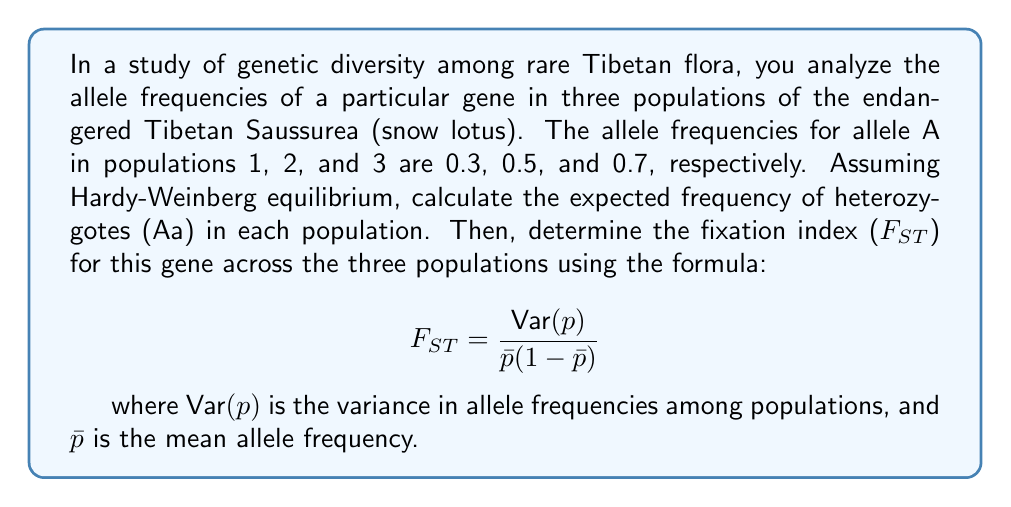Give your solution to this math problem. Let's approach this problem step by step:

1. Calculate the frequency of heterozygotes in each population:
   Under Hardy-Weinberg equilibrium, the frequency of heterozygotes is given by $2pq$, where $p$ is the frequency of allele A and $q = 1-p$ is the frequency of the other allele.

   Population 1: $2p(1-p) = 2(0.3)(0.7) = 0.42$
   Population 2: $2p(1-p) = 2(0.5)(0.5) = 0.50$
   Population 3: $2p(1-p) = 2(0.7)(0.3) = 0.42$

2. Calculate the mean allele frequency $\bar{p}$:
   $\bar{p} = \frac{0.3 + 0.5 + 0.7}{3} = 0.5$

3. Calculate the variance in allele frequencies $\text{Var}(p)$:
   $\text{Var}(p) = \frac{\sum(p_i - \bar{p})^2}{n}$
   
   $\text{Var}(p) = \frac{(0.3-0.5)^2 + (0.5-0.5)^2 + (0.7-0.5)^2}{3}$
   
   $\text{Var}(p) = \frac{0.04 + 0 + 0.04}{3} = \frac{0.08}{3} = 0.0267$

4. Calculate $F_{ST}$ using the given formula:
   $$ F_{ST} = \frac{\text{Var}(p)}{\bar{p}(1-\bar{p})} = \frac{0.0267}{0.5(1-0.5)} = \frac{0.0267}{0.25} = 0.1068 $$
Answer: The expected frequencies of heterozygotes (Aa) in populations 1, 2, and 3 are 0.42, 0.50, and 0.42, respectively. The fixation index (F_ST) for this gene across the three populations is 0.1068. 